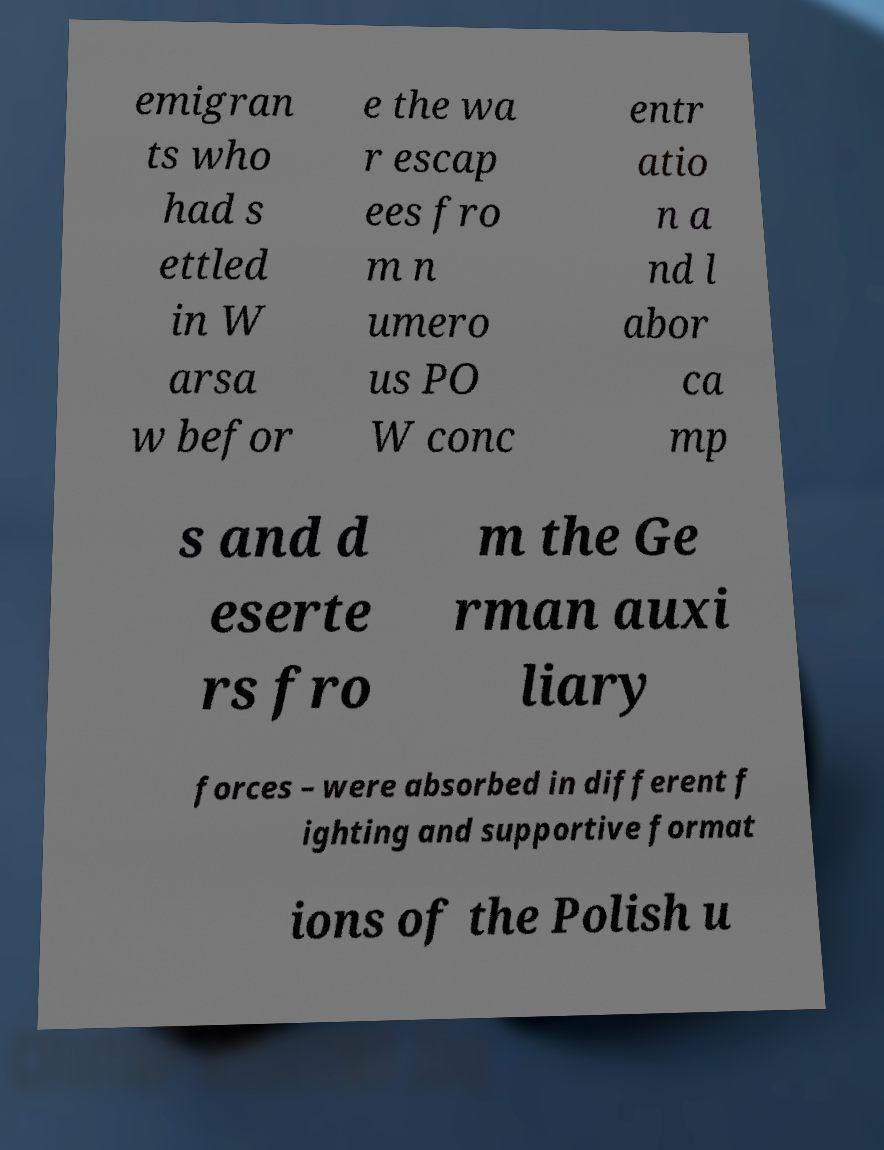Can you accurately transcribe the text from the provided image for me? emigran ts who had s ettled in W arsa w befor e the wa r escap ees fro m n umero us PO W conc entr atio n a nd l abor ca mp s and d eserte rs fro m the Ge rman auxi liary forces – were absorbed in different f ighting and supportive format ions of the Polish u 